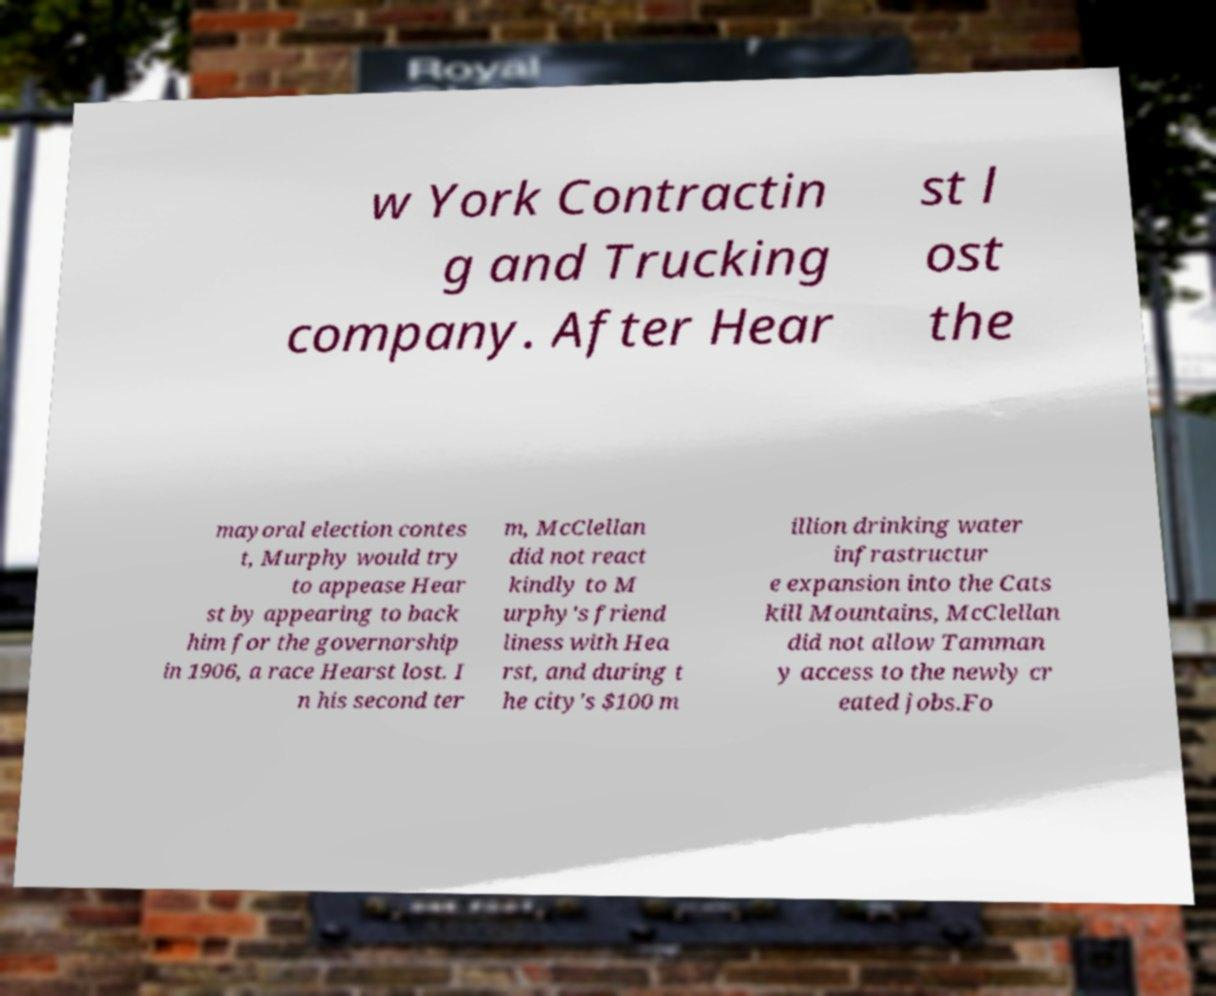There's text embedded in this image that I need extracted. Can you transcribe it verbatim? w York Contractin g and Trucking company. After Hear st l ost the mayoral election contes t, Murphy would try to appease Hear st by appearing to back him for the governorship in 1906, a race Hearst lost. I n his second ter m, McClellan did not react kindly to M urphy's friend liness with Hea rst, and during t he city's $100 m illion drinking water infrastructur e expansion into the Cats kill Mountains, McClellan did not allow Tamman y access to the newly cr eated jobs.Fo 